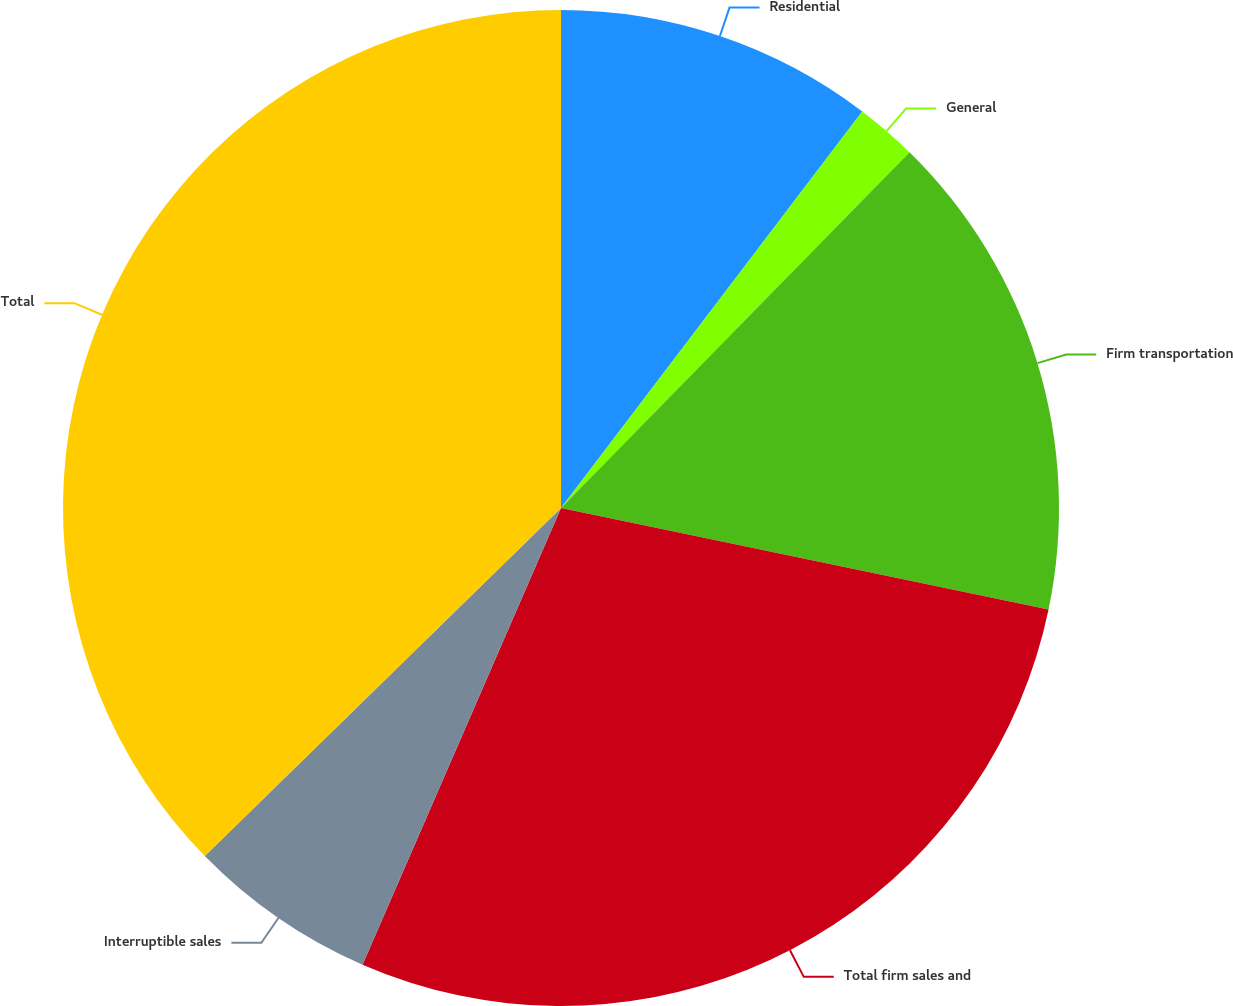Convert chart to OTSL. <chart><loc_0><loc_0><loc_500><loc_500><pie_chart><fcel>Residential<fcel>General<fcel>Firm transportation<fcel>Total firm sales and<fcel>Interruptible sales<fcel>Total<nl><fcel>10.34%<fcel>2.0%<fcel>15.93%<fcel>28.26%<fcel>6.16%<fcel>37.32%<nl></chart> 